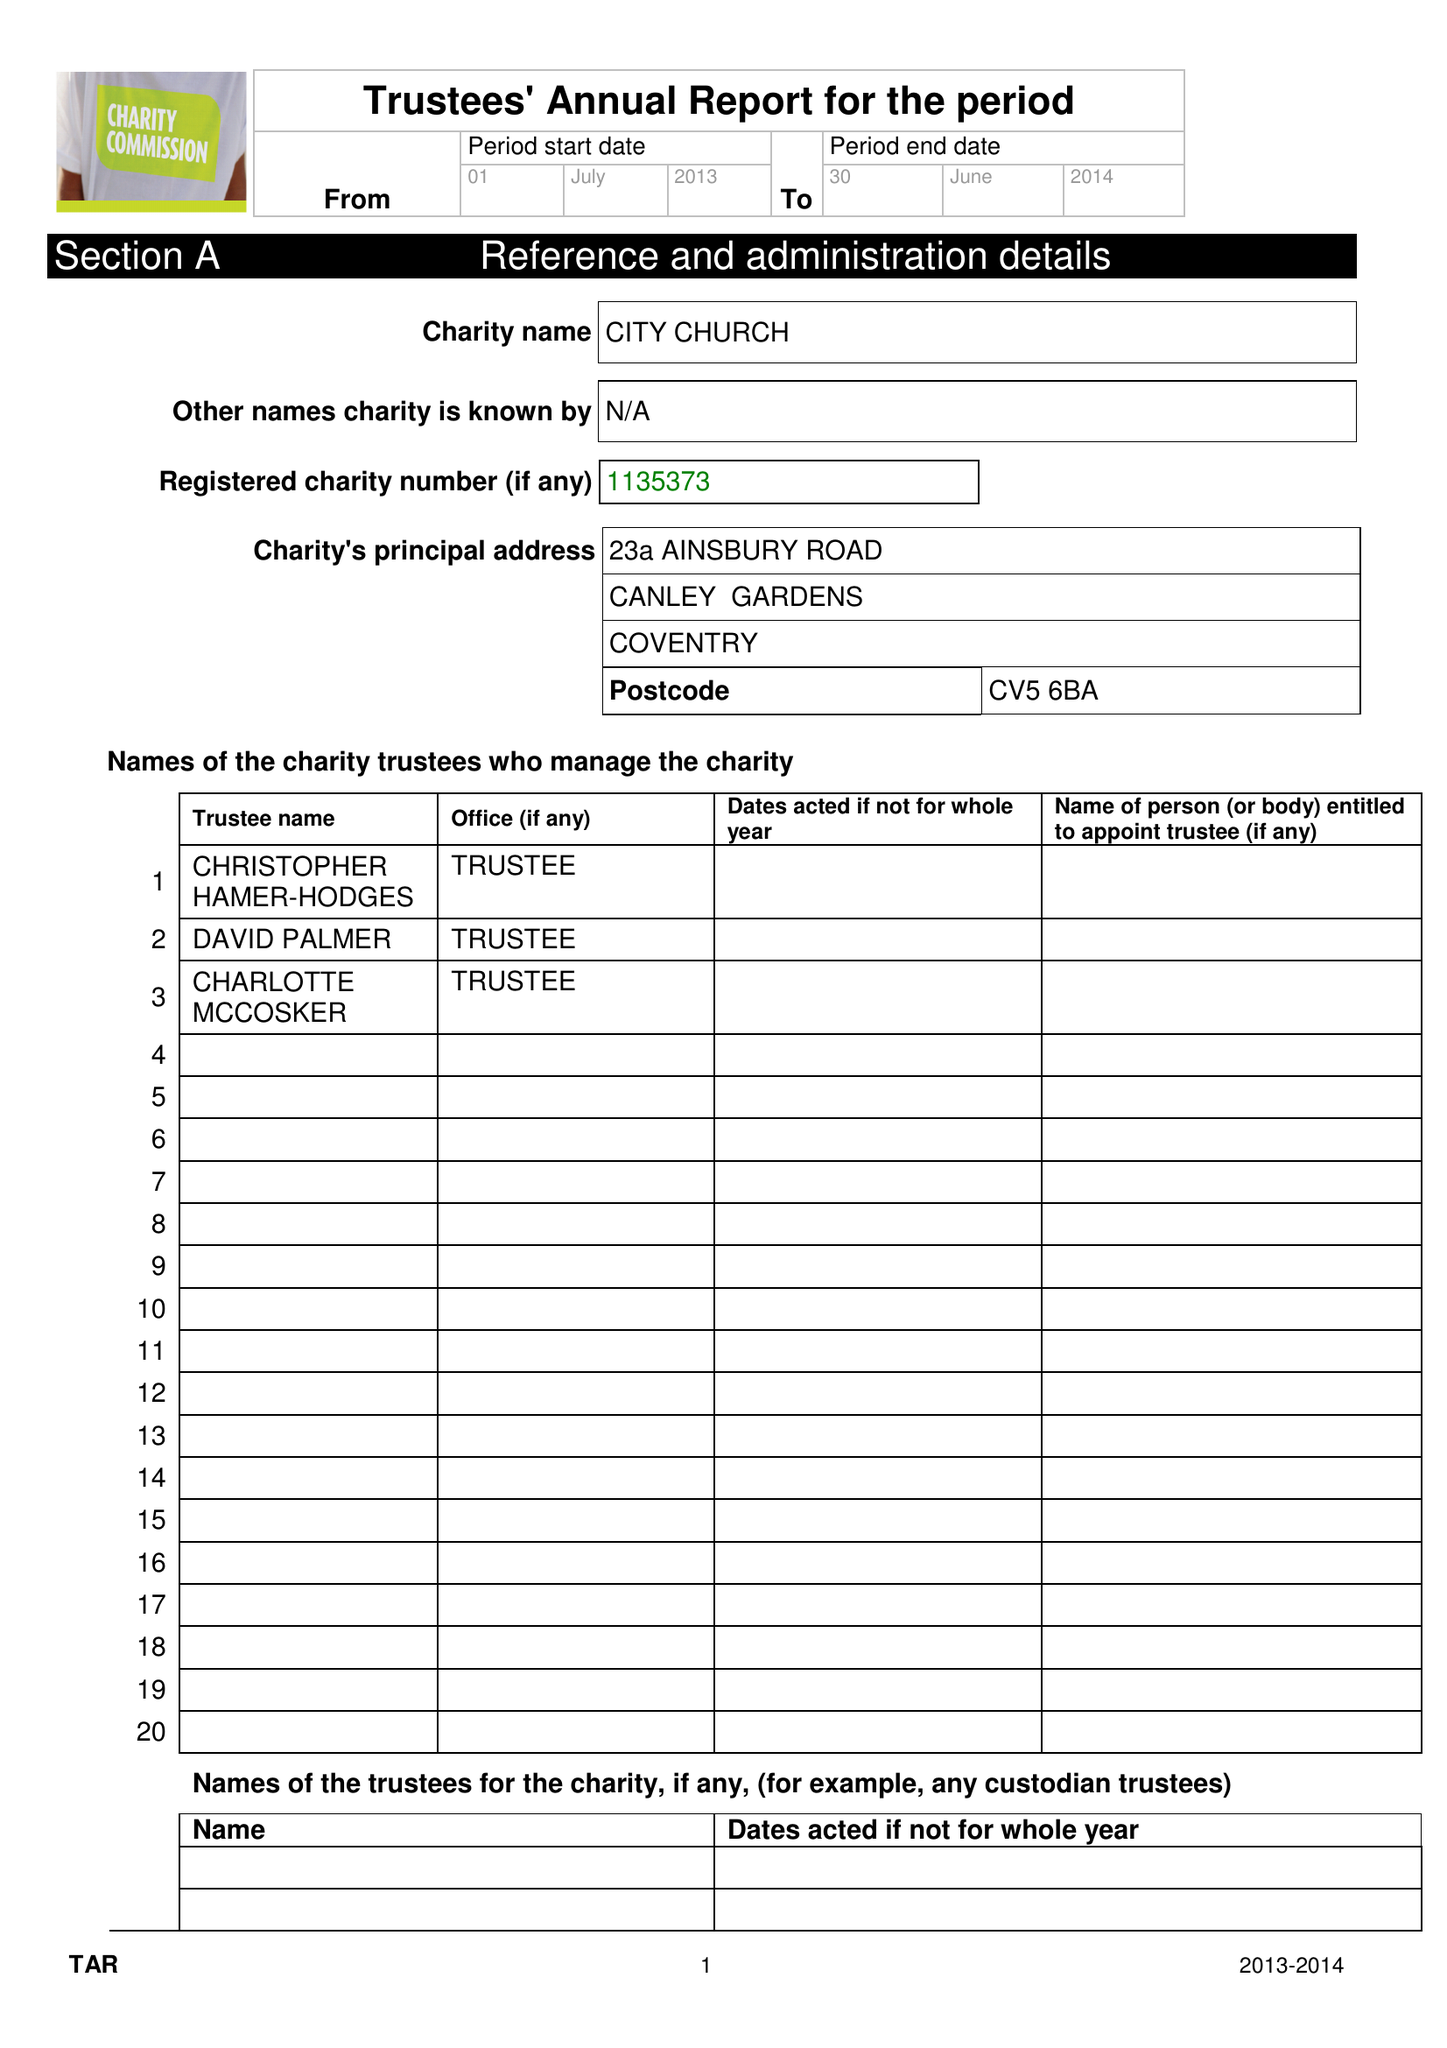What is the value for the charity_name?
Answer the question using a single word or phrase. City Church Coventry 